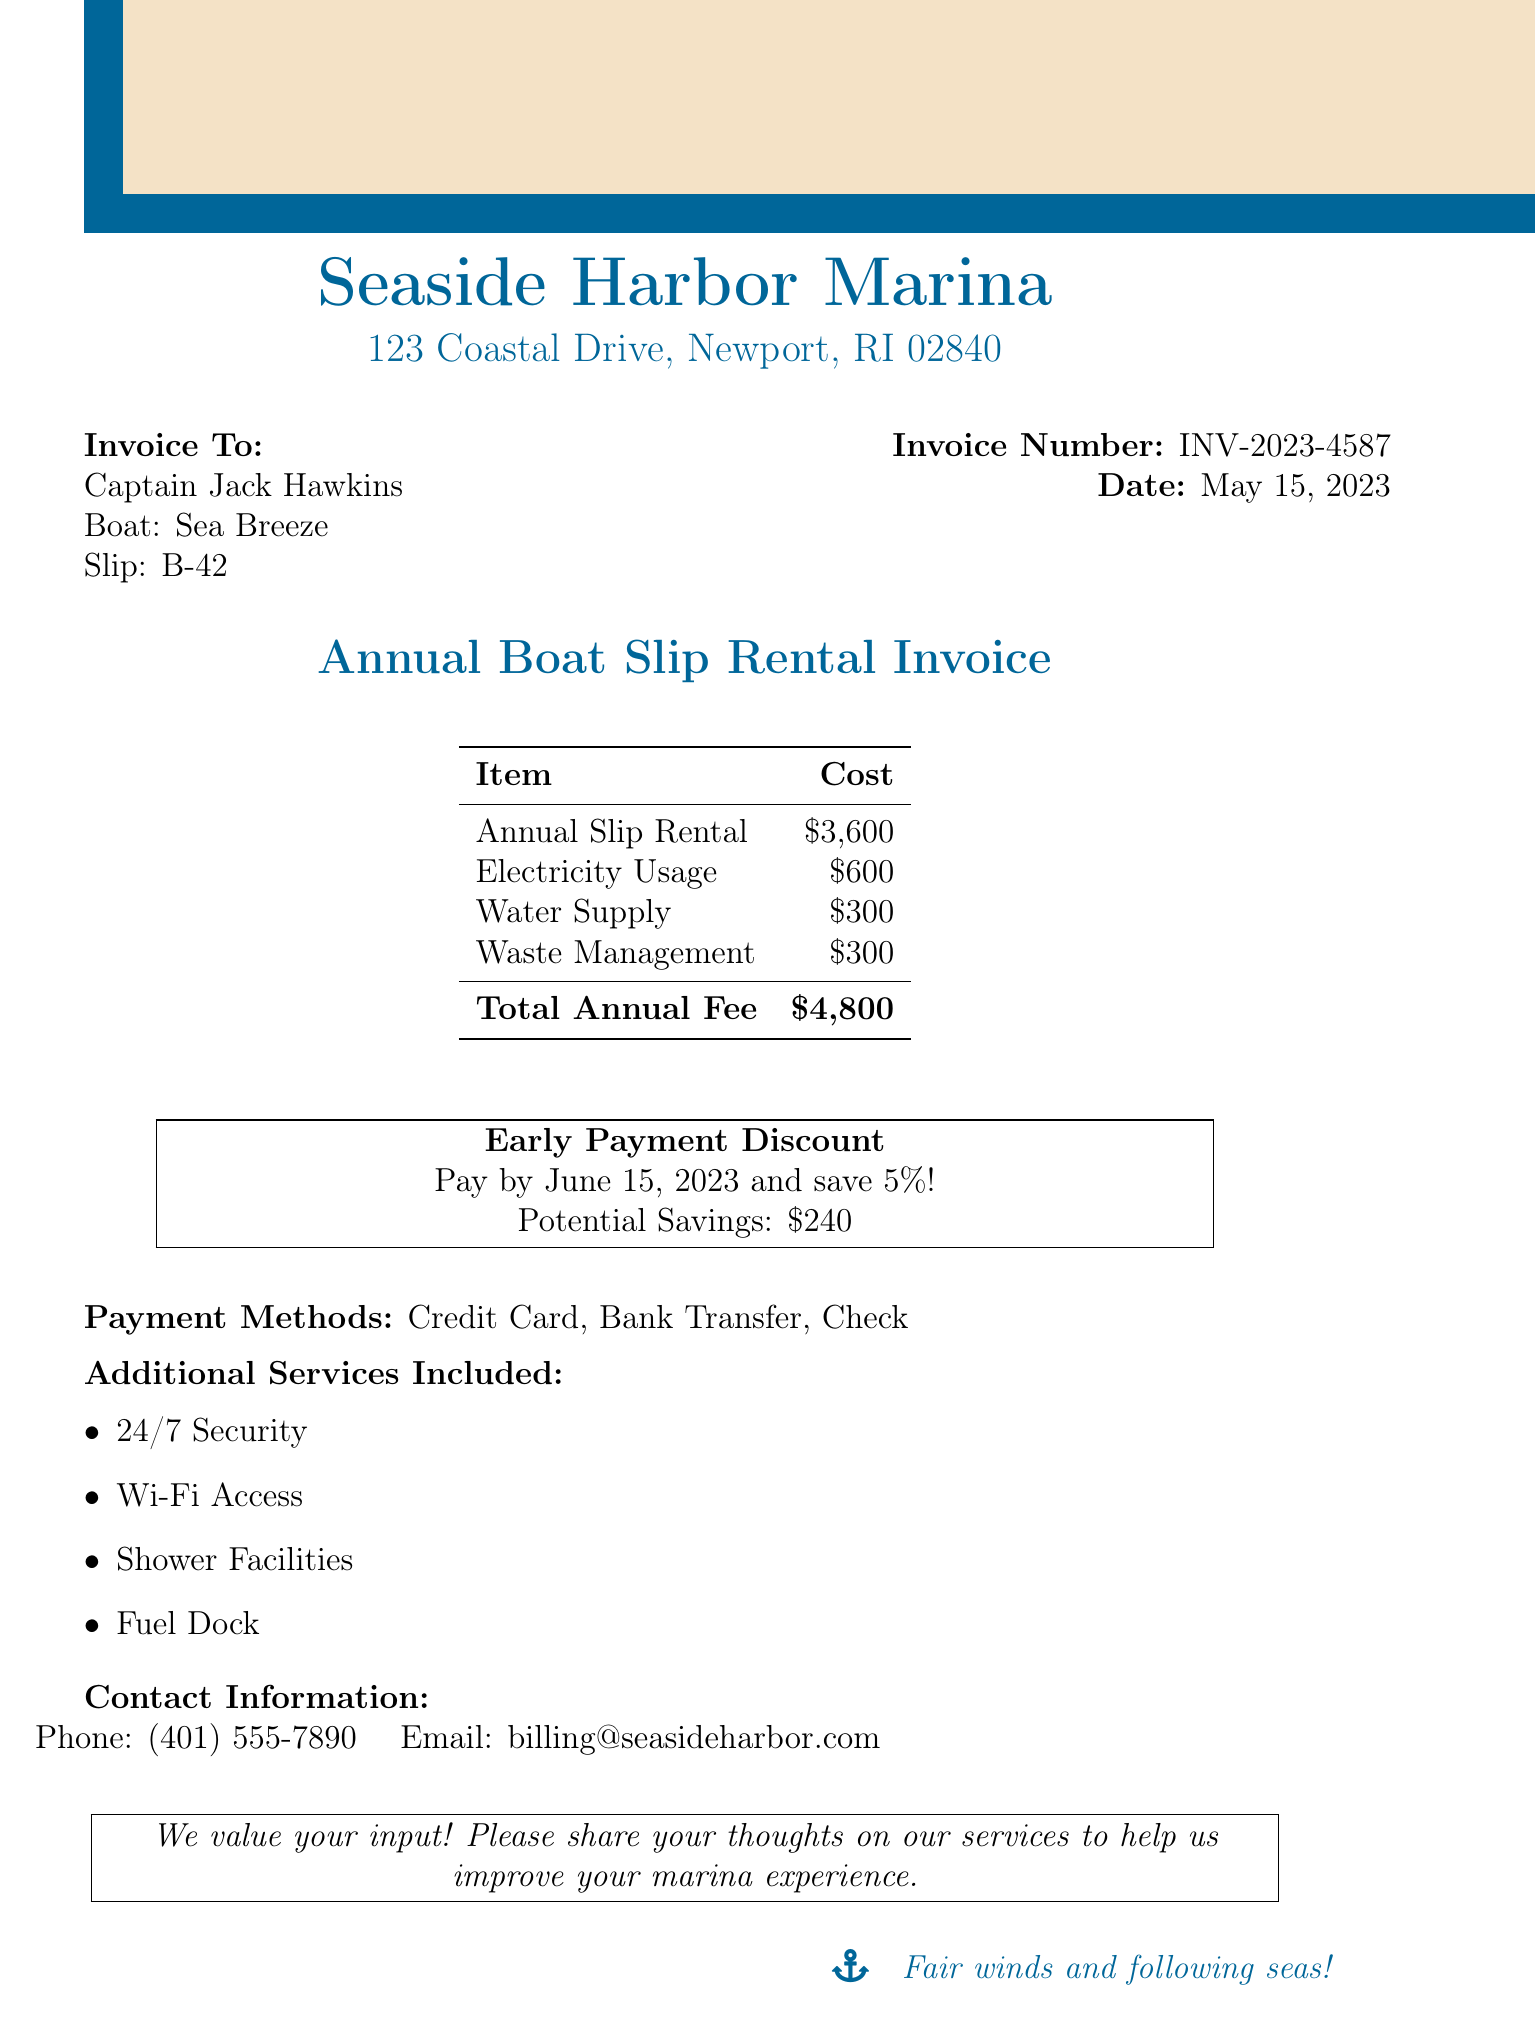What is the annual boat slip rental fee? The annual fee is listed directly in the document.
Answer: $4,800 What is the invoice number? The invoice number is explicitly stated in the document.
Answer: INV-2023-4587 What is the deadline for the early payment discount? The deadline for the early payment discount is mentioned in the discount section.
Answer: June 15, 2023 How much can be saved with early payment? The potential savings are detailed under the early payment discount.
Answer: $240 What additional services are included? The document lists the additional services provided.
Answer: 24/7 Security, Wi-Fi Access, Shower Facilities, Fuel Dock What is the cost of electricity usage? The cost of electricity usage is broken down in the services breakdown.
Answer: $600 What are the payment methods available? The document lists the payment methods available for this invoice.
Answer: Credit Card, Bank Transfer, Check What is the name of the marina? The name of the marina is displayed at the top of the document.
Answer: Seaside Harbor Marina Who is the invoice addressed to? The document specifies the name of the customer.
Answer: Captain Jack Hawkins 